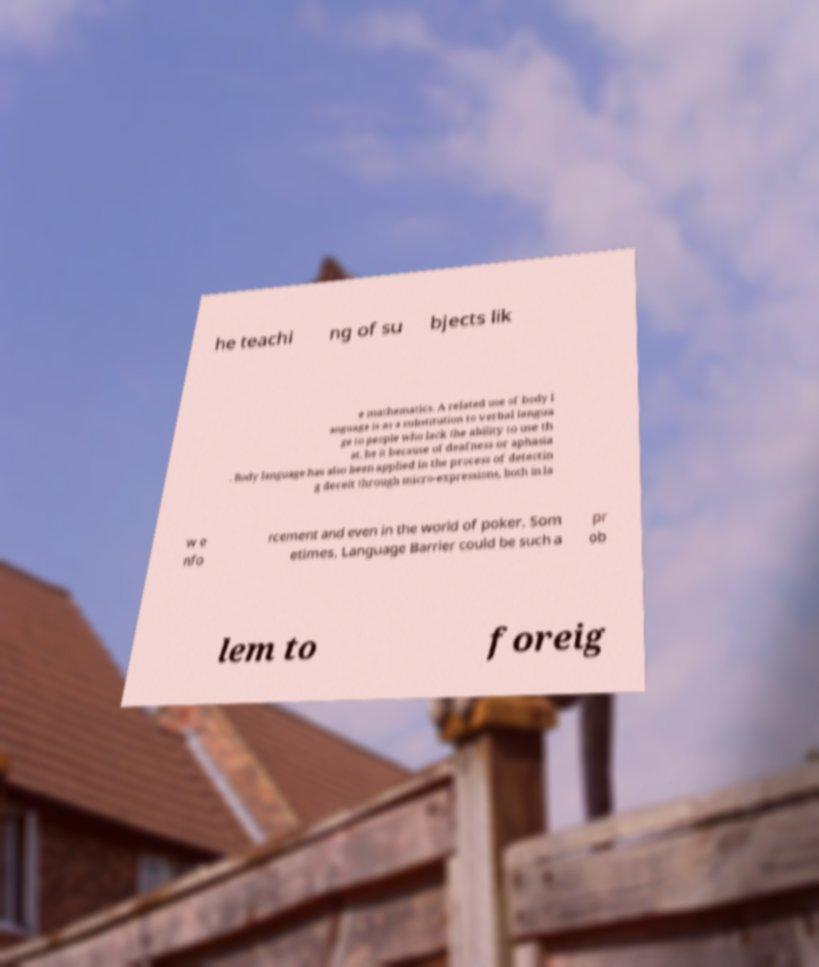I need the written content from this picture converted into text. Can you do that? he teachi ng of su bjects lik e mathematics. A related use of body l anguage is as a substitution to verbal langua ge to people who lack the ability to use th at, be it because of deafness or aphasia . Body language has also been applied in the process of detectin g deceit through micro-expressions, both in la w e nfo rcement and even in the world of poker. Som etimes, Language Barrier could be such a pr ob lem to foreig 